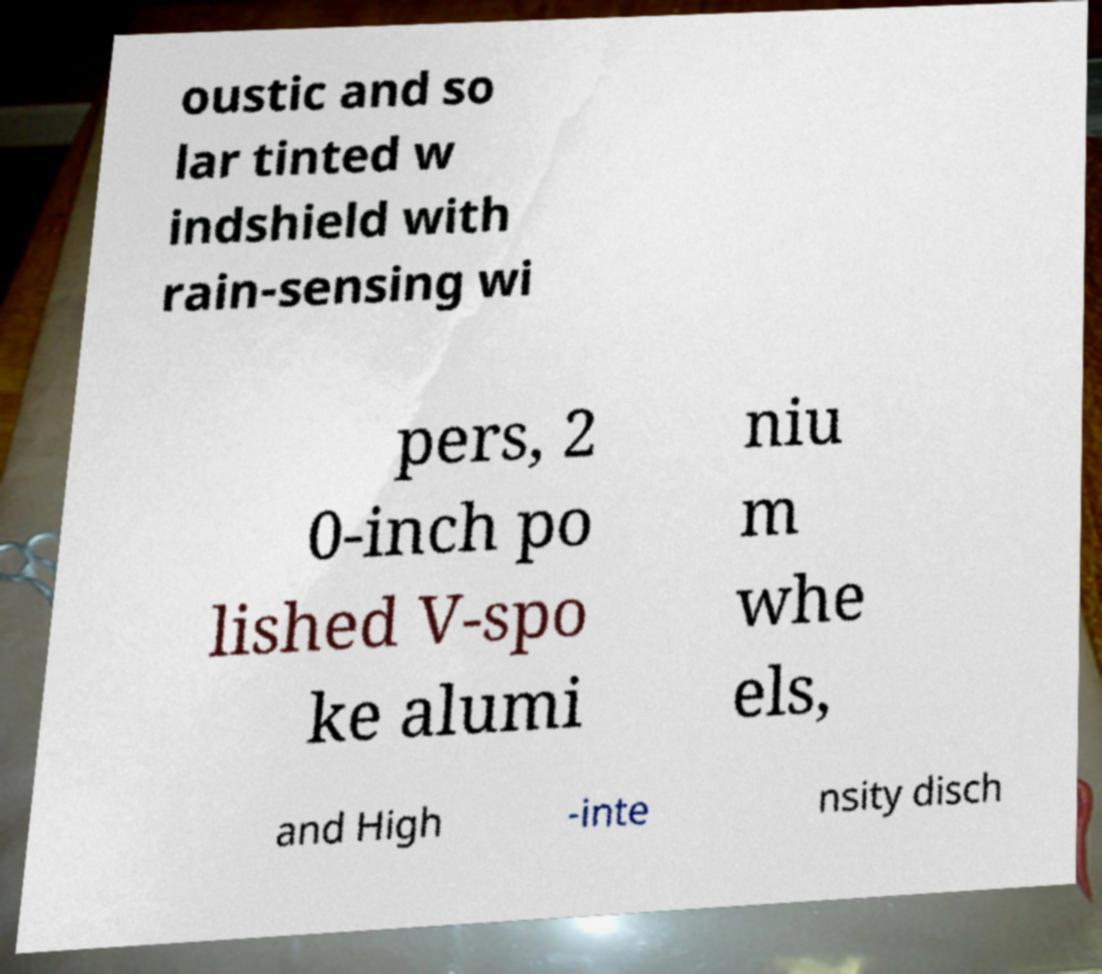Could you extract and type out the text from this image? oustic and so lar tinted w indshield with rain-sensing wi pers, 2 0-inch po lished V-spo ke alumi niu m whe els, and High -inte nsity disch 